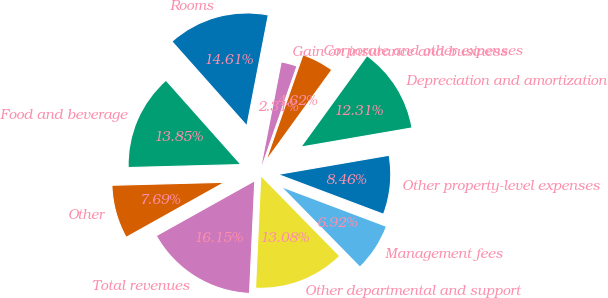<chart> <loc_0><loc_0><loc_500><loc_500><pie_chart><fcel>Rooms<fcel>Food and beverage<fcel>Other<fcel>Total revenues<fcel>Other departmental and support<fcel>Management fees<fcel>Other property-level expenses<fcel>Depreciation and amortization<fcel>Corporate and other expenses<fcel>Gain on insurance and business<nl><fcel>14.61%<fcel>13.85%<fcel>7.69%<fcel>16.15%<fcel>13.08%<fcel>6.92%<fcel>8.46%<fcel>12.31%<fcel>4.62%<fcel>2.31%<nl></chart> 